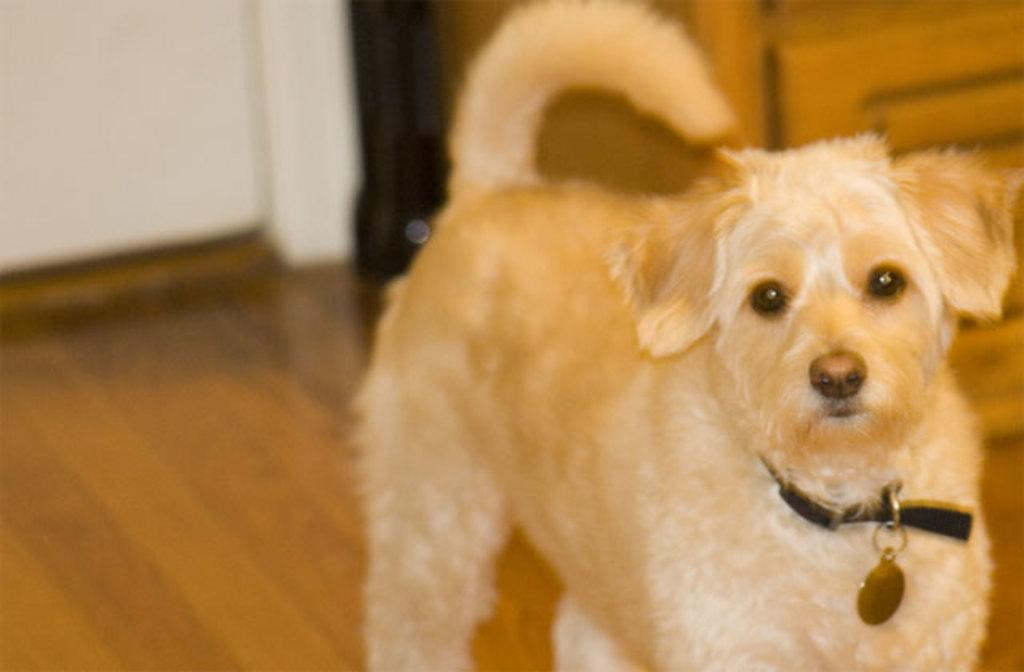What is the main subject in the center of the image? There is a dog in the center of the image. Where is the dog located? The dog is on the floor. What can be seen in the background of the image? There is a door and a wall in the background of the image. What type of trees are visible on the page in the image? There are no trees or pages present in the image; it features a dog on the floor with a door and a wall in the background. 